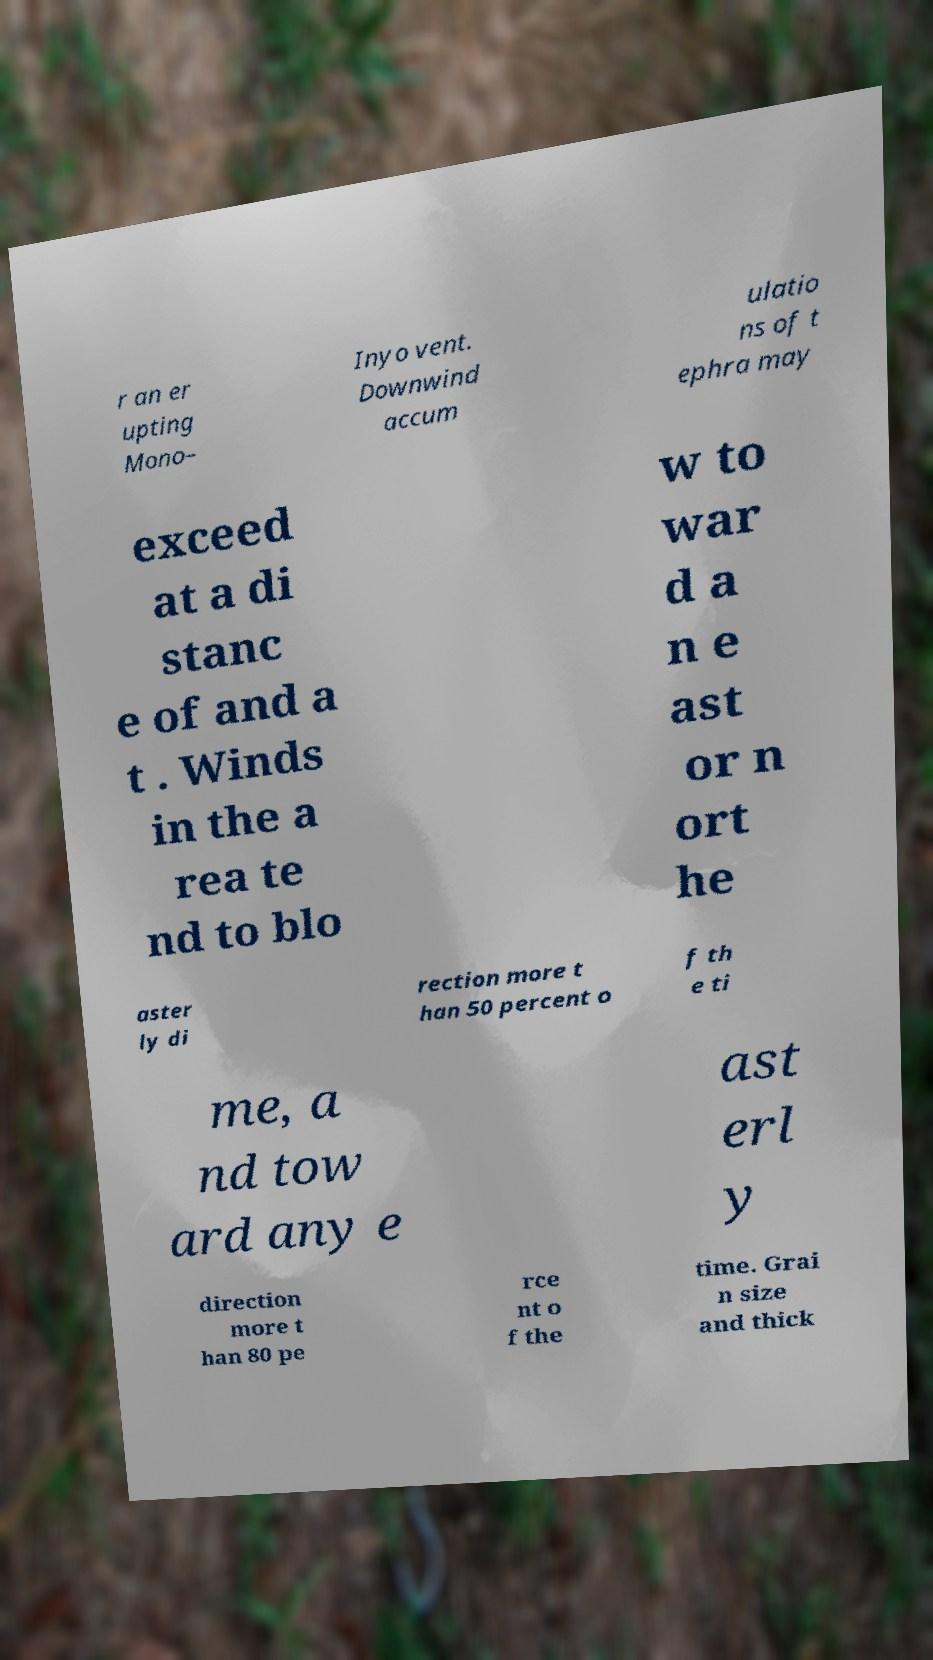I need the written content from this picture converted into text. Can you do that? r an er upting Mono– Inyo vent. Downwind accum ulatio ns of t ephra may exceed at a di stanc e of and a t . Winds in the a rea te nd to blo w to war d a n e ast or n ort he aster ly di rection more t han 50 percent o f th e ti me, a nd tow ard any e ast erl y direction more t han 80 pe rce nt o f the time. Grai n size and thick 